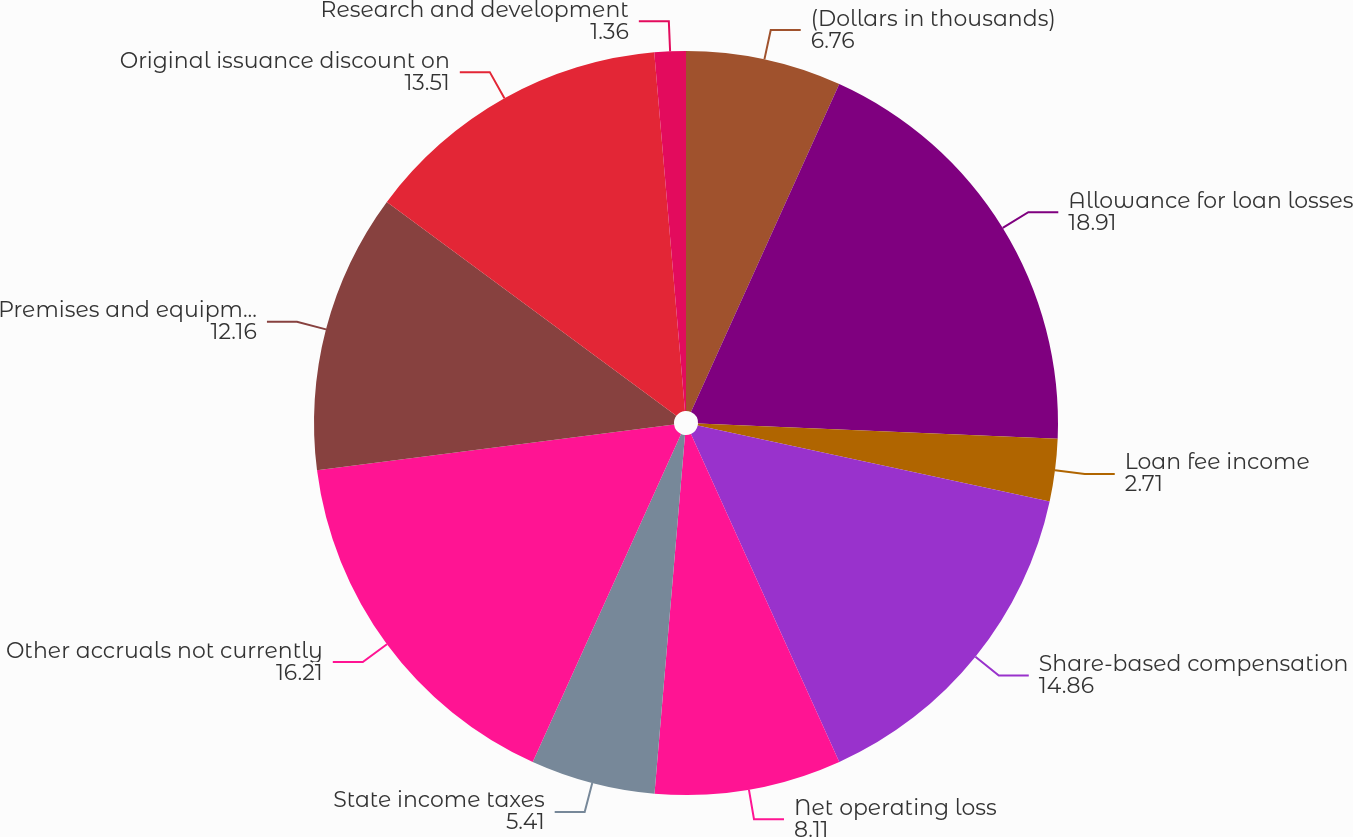Convert chart. <chart><loc_0><loc_0><loc_500><loc_500><pie_chart><fcel>(Dollars in thousands)<fcel>Allowance for loan losses<fcel>Loan fee income<fcel>Share-based compensation<fcel>Net operating loss<fcel>State income taxes<fcel>Other accruals not currently<fcel>Premises and equipment and<fcel>Original issuance discount on<fcel>Research and development<nl><fcel>6.76%<fcel>18.91%<fcel>2.71%<fcel>14.86%<fcel>8.11%<fcel>5.41%<fcel>16.21%<fcel>12.16%<fcel>13.51%<fcel>1.36%<nl></chart> 